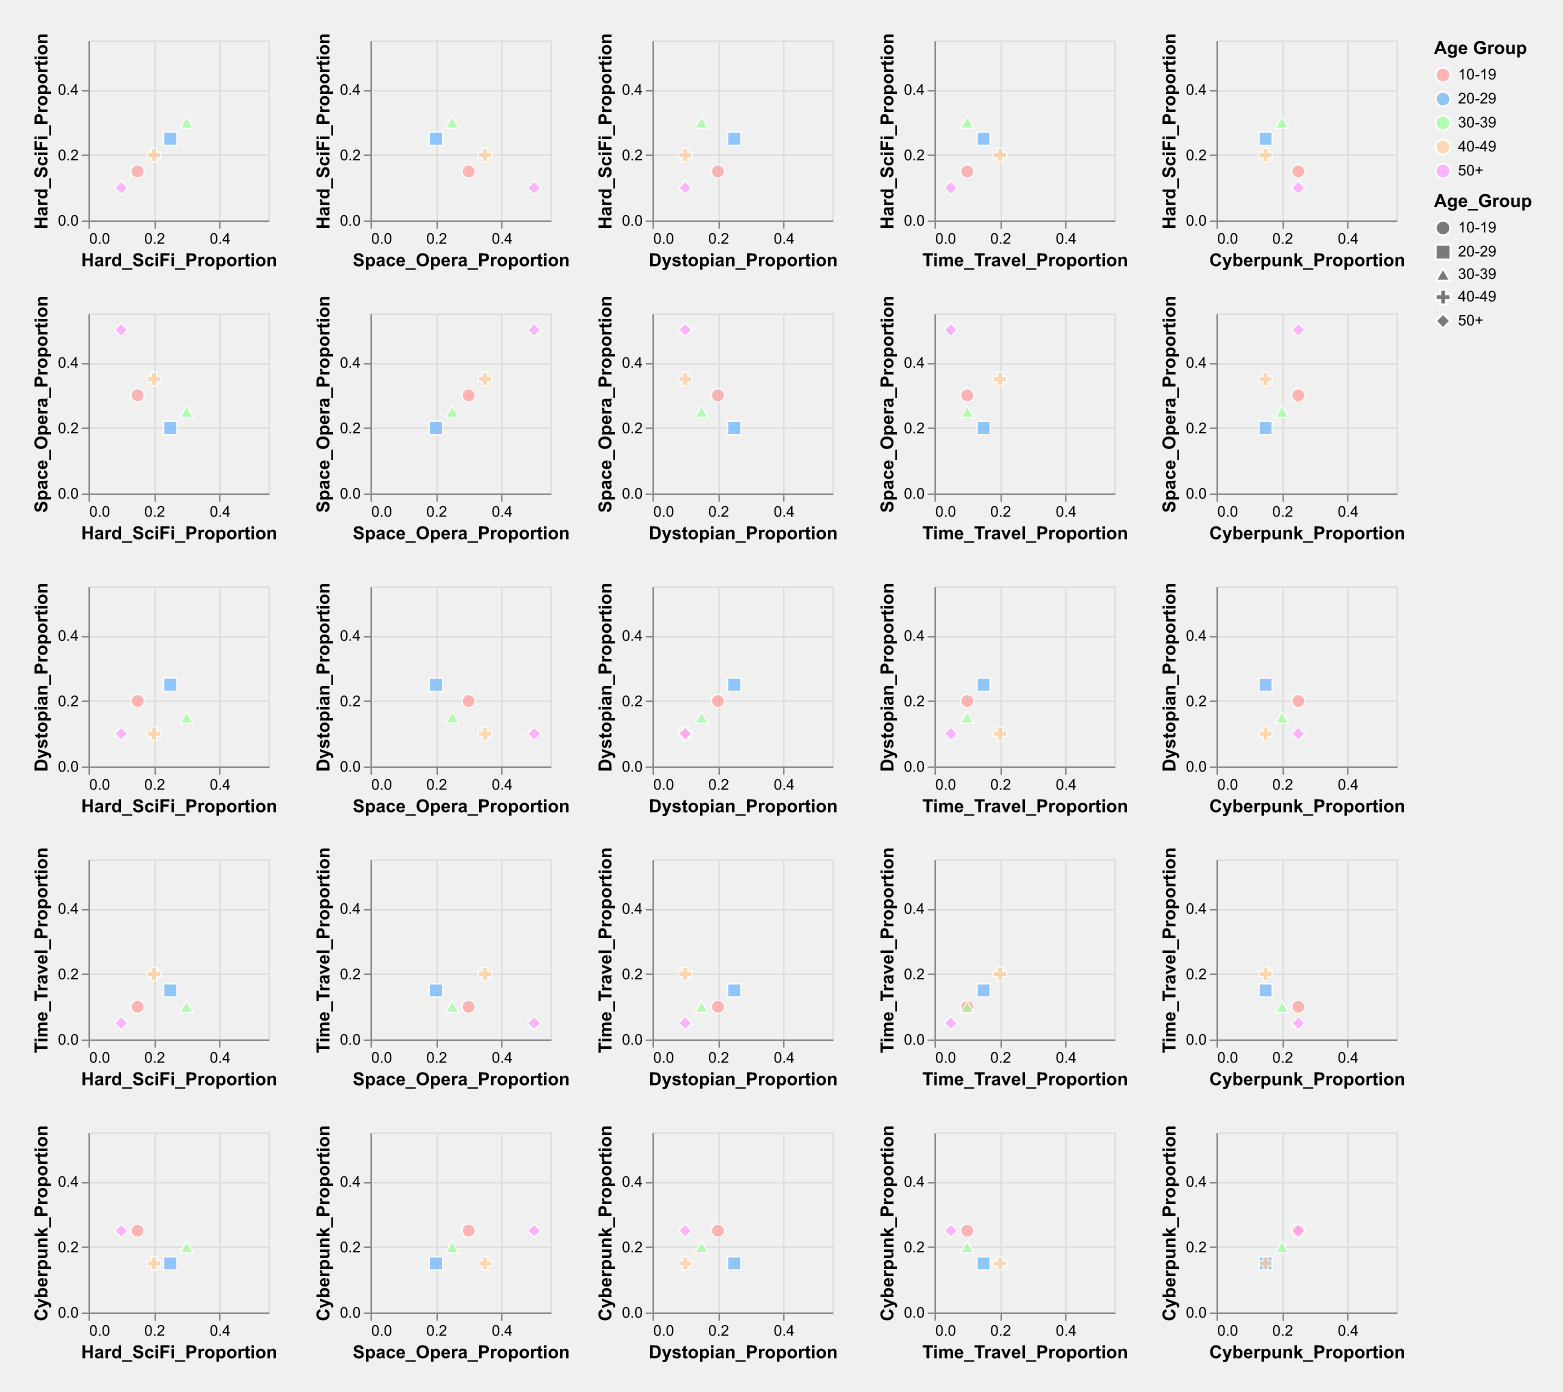What is the title of the plot? The title is usually located at the top of the figure and summarizes the content. This plot's title is helpful because it gives an overview of what is being compared.
Answer: Trends in Science Fiction Writing Styles and Their Popularity Across Different Age Groups Which Age Group is represented by the color blue? Colors help distinguish different groups quickly. In this plot, the legend indicates different age groups using various colors. The color blue corresponds to the Age Group 20-29.
Answer: 20-29 Does the 50+ Age Group show the highest proportion of any single style? If so, which style? We need to check each style's highest proportion value and compare it with others. In the plot, the 50+ Age Group has the highest proportion in the Space Opera category at 0.50.
Answer: Yes, Space Opera How does the proportion of Dystopian writing for the 20-29 Age Group compare to the proportions for the 30-39 and 50+ Age Groups? To answer this, compare the values of the Dystopian proportions from the matrix. The proportion for 20-29 is 0.25, 30-39 is 0.15, and 50+ is 0.10.
Answer: Higher than both 30-39 and 50+ What is the general trend of Hard SciFi Proportion across different age groups? By examining the plot cells for Hard SciFi proportions across different age groups, we can observe the trend. The proportion increases from younger to middle age groups (peaks at age 30-39) and then decreases for older age groups.
Answer: Increases then decreases Which two age groups have the most similar preferences across all writing styles? Analyze the scatter plot matrix to check for age groups with similar proportions in various styles since similar points will be close on different scatter plots. The groups that tend to have similar values are the age groups 20-29 and 40-49.
Answer: 20-29 and 40-49 Is there any noticeable correlation between Hard SciFi and Cyberpunk proportions? By observing the scatter plot cell where Hard SciFi is on one axis and Cyberpunk is on the other, we look for a pattern in how the points are distributed. There doesn't seem to be a strong correlation as the points are more scattered.
Answer: No What proportion of Space Opera is represented by individuals aged 10-19? Locate the intersection cell between Space Opera and Age Group 10-19 to find the proportion. Cross-referencing the data in the cell, it shows 0.30 for the 10-19 Age Group.
Answer: 0.30 What is the most and least preferred writing style for the age group 30-39? By checking the points for the 30-39 age group across different styles, Time Travel has the lowest proportion (0.10) and Hard SciFi has the highest (0.30).
Answer: Most: Hard SciFi, Least: Time Travel Do any Age Groups show a balanced preference for all writing styles? Analyzing the matrix, we identify any age group that has roughly equal proportions across all categories. The proportions for each group vary significantly, so none show a particularly balanced preference.
Answer: No 